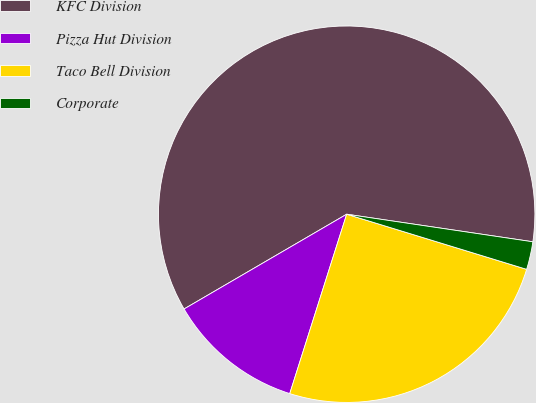Convert chart to OTSL. <chart><loc_0><loc_0><loc_500><loc_500><pie_chart><fcel>KFC Division<fcel>Pizza Hut Division<fcel>Taco Bell Division<fcel>Corporate<nl><fcel>60.74%<fcel>11.71%<fcel>25.16%<fcel>2.39%<nl></chart> 